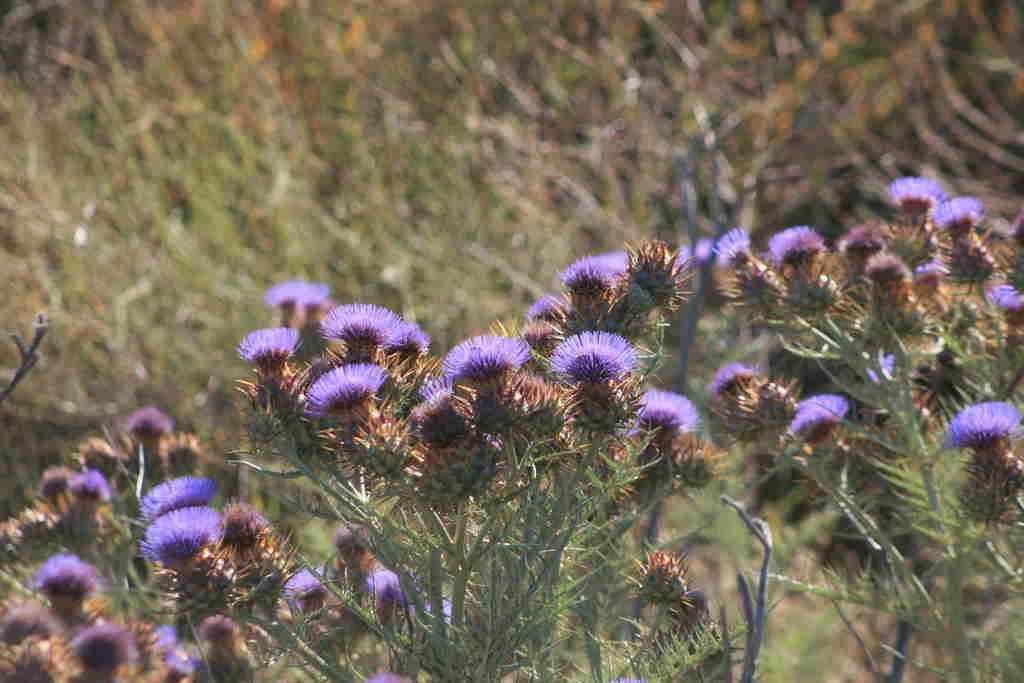Describe this image in one or two sentences. In this picture we can see some flowers to the plants. 